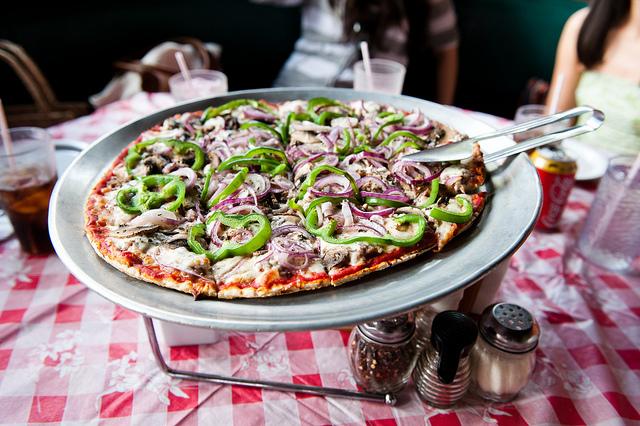Is this a thick or thin crust pizza?
Concise answer only. Thin. Does the pizza look flavorful?
Give a very brief answer. Yes. What are the purple thin slices?
Quick response, please. Onions. 